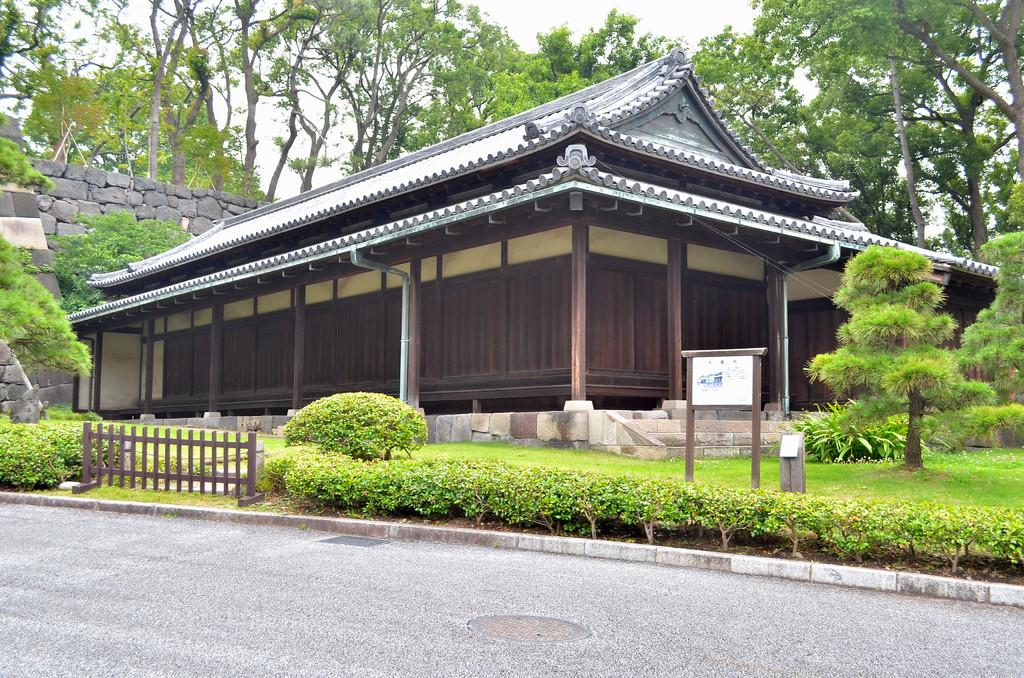What is the main structure in the center of the image? There is a house with stairs in the center of the image. What can be seen in the background of the image? There are trees, a wall, plants, a board, and a railing in the background of the image. What is at the bottom of the image? There is a road at the bottom of the image. Where is the bedroom located in the image? There is no bedroom visible in the image; it only shows a house with stairs, a background with trees, a wall, plants, a board, and a railing, and a road at the bottom. 